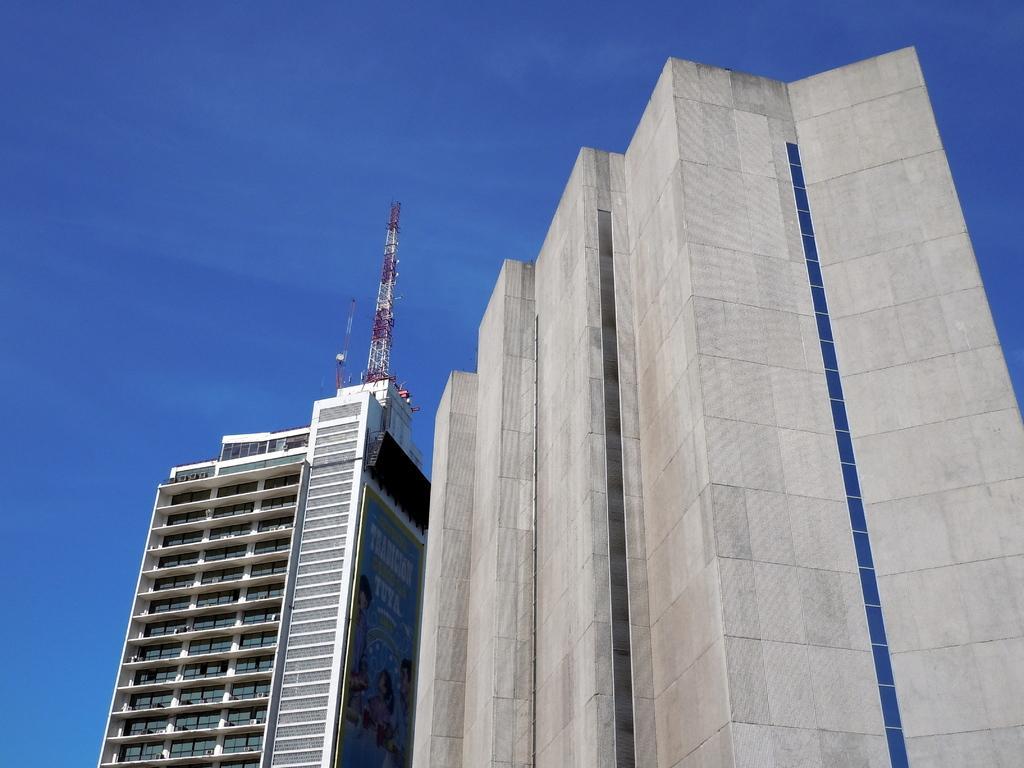Can you describe this image briefly? In this image I can see there is a building and there is an antenna on top of the building and the sky is clear. 